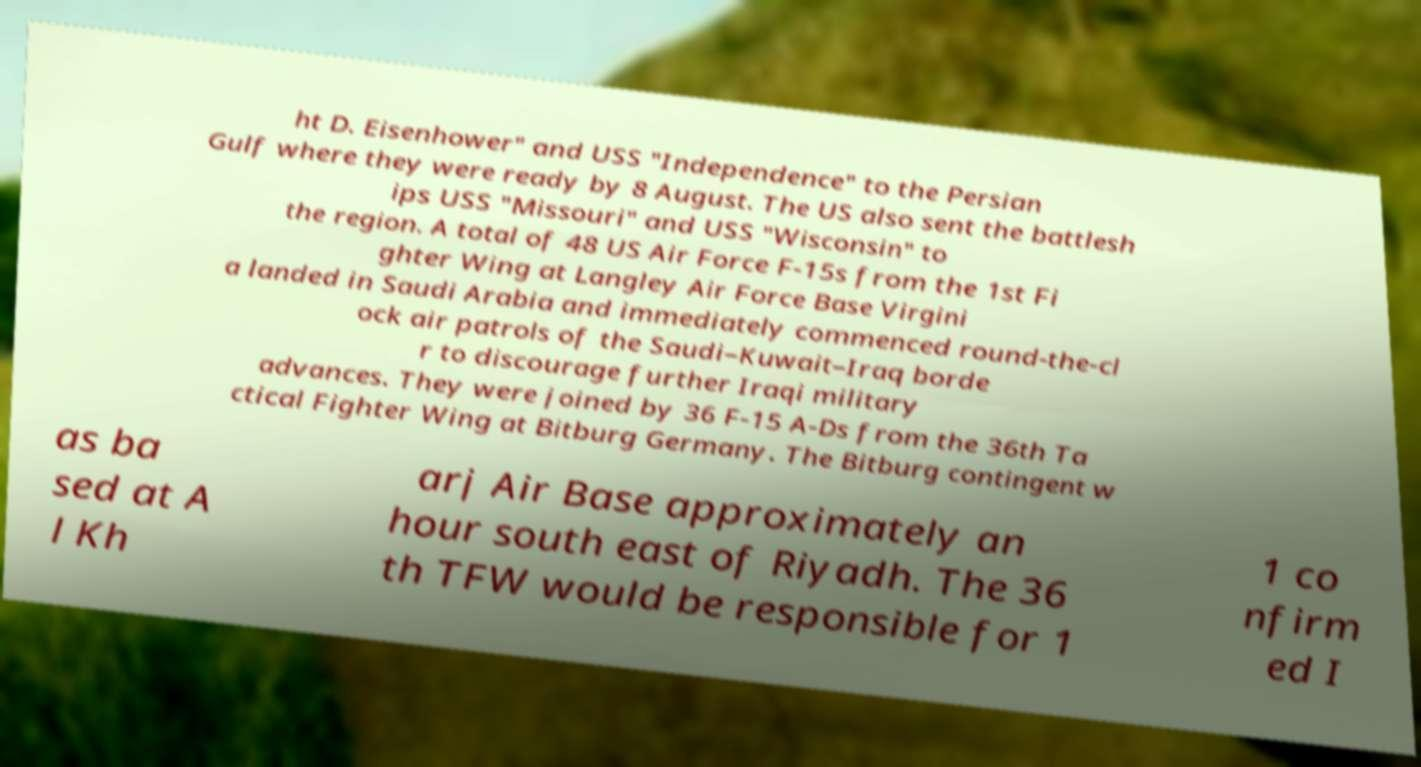Can you accurately transcribe the text from the provided image for me? ht D. Eisenhower" and USS "Independence" to the Persian Gulf where they were ready by 8 August. The US also sent the battlesh ips USS "Missouri" and USS "Wisconsin" to the region. A total of 48 US Air Force F-15s from the 1st Fi ghter Wing at Langley Air Force Base Virgini a landed in Saudi Arabia and immediately commenced round-the-cl ock air patrols of the Saudi–Kuwait–Iraq borde r to discourage further Iraqi military advances. They were joined by 36 F-15 A-Ds from the 36th Ta ctical Fighter Wing at Bitburg Germany. The Bitburg contingent w as ba sed at A l Kh arj Air Base approximately an hour south east of Riyadh. The 36 th TFW would be responsible for 1 1 co nfirm ed I 